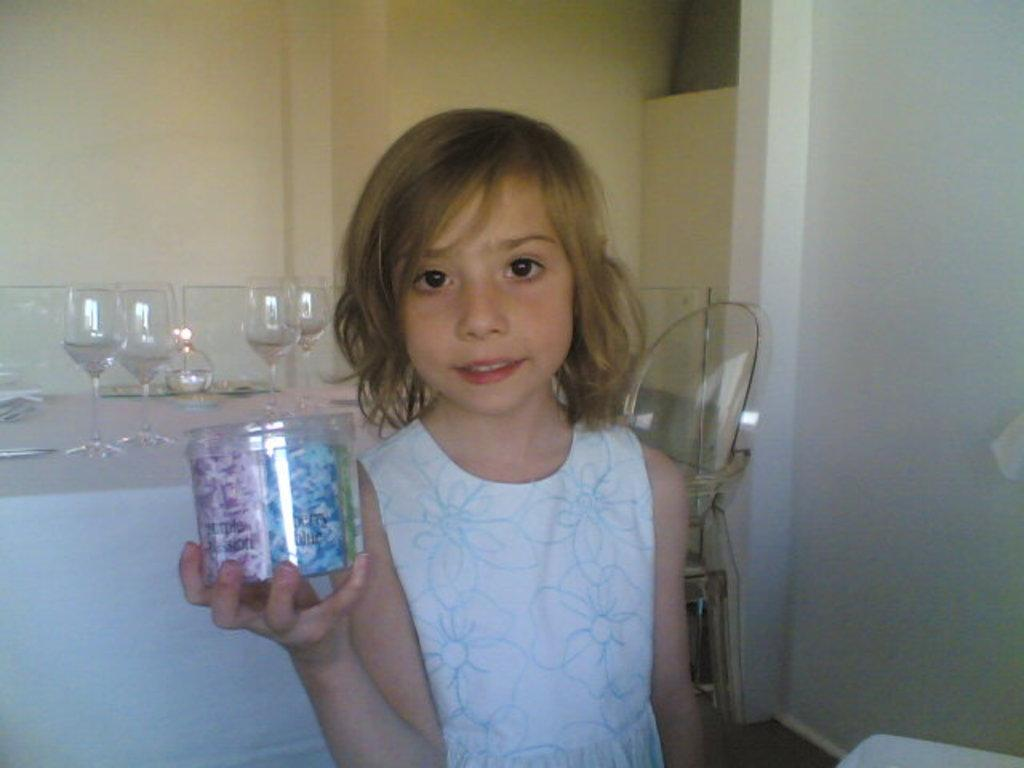Who is the main subject in the image? There is a girl standing in the front of the image. What is the girl holding in her hand? The girl is holding an object in her hand. What can be seen in the background of the image? There are glasses and a wall in the background of the image. What is the color of the wall in the background? The wall is yellow in color. What type of cork can be seen on the girl's skin in the image? There is no cork or mention of skin in the image; it features a girl standing with an object in her hand and a yellow wall in the background. 